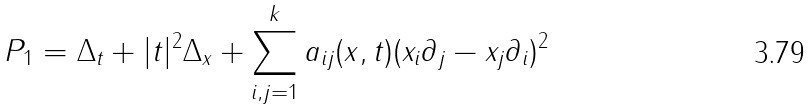Convert formula to latex. <formula><loc_0><loc_0><loc_500><loc_500>P _ { 1 } = \Delta _ { t } + | t | ^ { 2 } \Delta _ { x } + \sum _ { i , j = 1 } ^ { k } a _ { i j } ( x , t ) ( x _ { i } \partial _ { j } - x _ { j } \partial _ { i } ) ^ { 2 }</formula> 